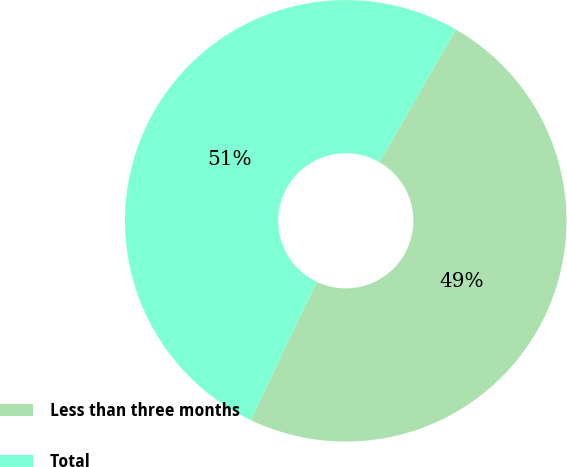<chart> <loc_0><loc_0><loc_500><loc_500><pie_chart><fcel>Less than three months<fcel>Total<nl><fcel>48.78%<fcel>51.22%<nl></chart> 